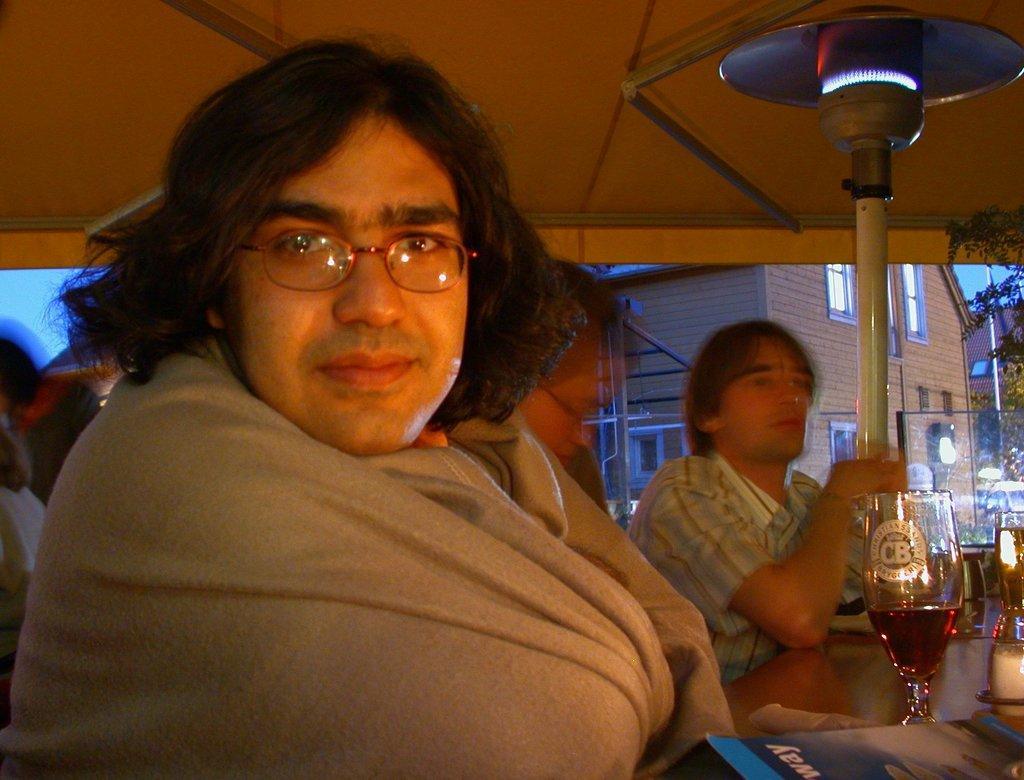How would you summarize this image in a sentence or two? In this picture I can see few people in front and on the right side of this picture I can see the table on which there are glasses and a book on which there is a word written and I see that these people are under the shed. In the background I can see the buildings, few trees and the lights. 